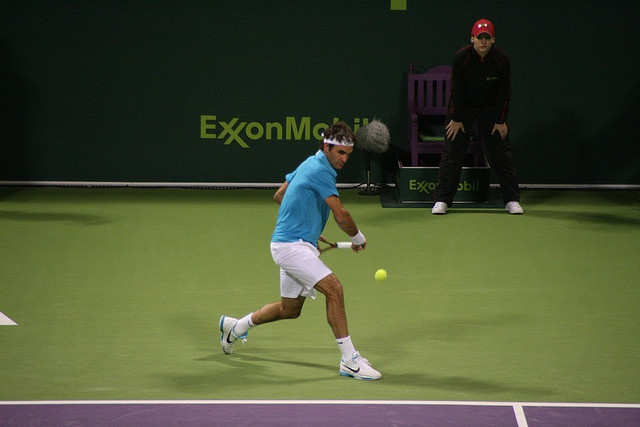Describe the objects in this image and their specific colors. I can see people in black, teal, lavender, maroon, and darkgray tones, people in black, maroon, olive, and brown tones, chair in black and purple tones, tennis racket in black, olive, and lightgray tones, and sports ball in black, khaki, and olive tones in this image. 